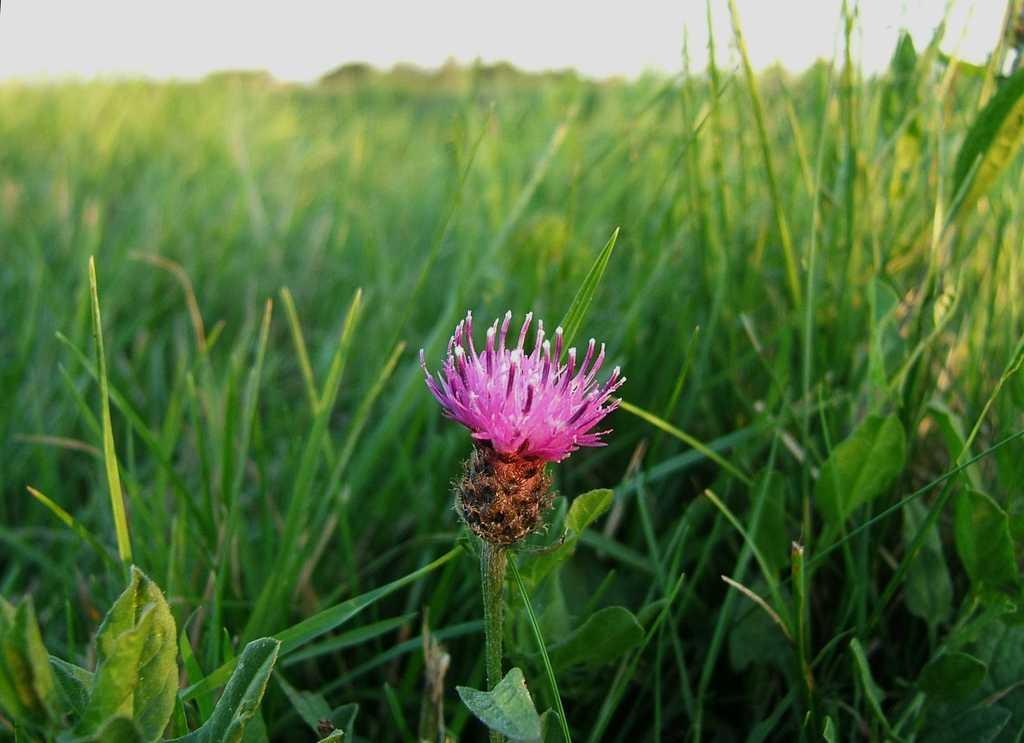What type of plant is in the image? There is a flower with a stem in the image. What can be seen in the background of the image? There is grass in the background of the image. What is visible at the top of the image? The sky is visible at the top of the image. What arithmetic problem is being solved in the image? There is no arithmetic problem present in the image. What list can be seen in the image? There is no list present in the image. 